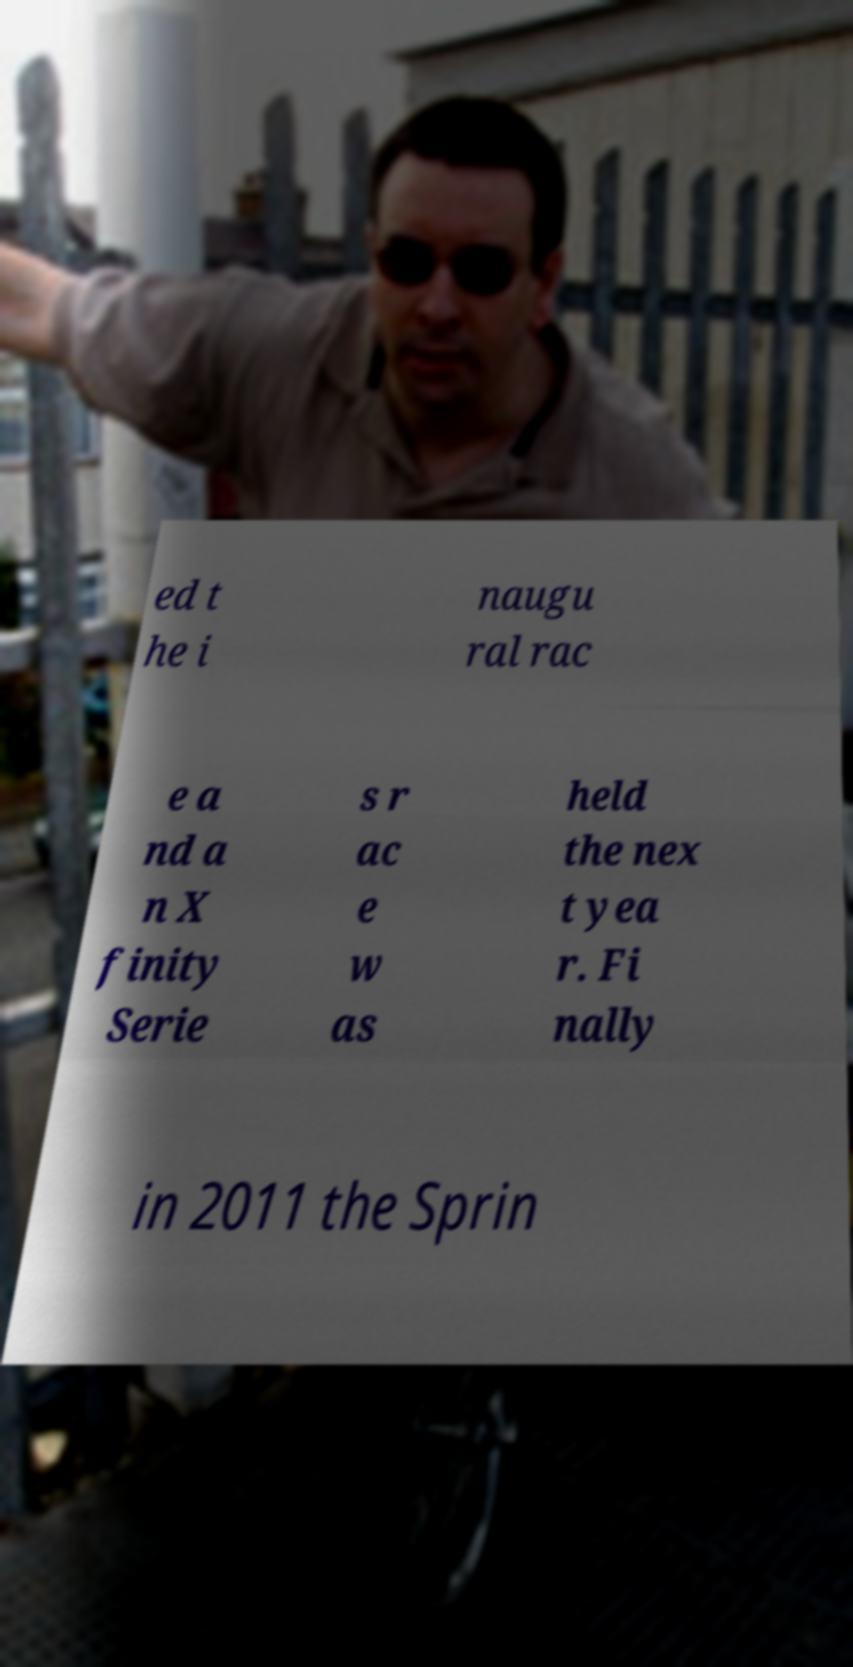Could you extract and type out the text from this image? ed t he i naugu ral rac e a nd a n X finity Serie s r ac e w as held the nex t yea r. Fi nally in 2011 the Sprin 